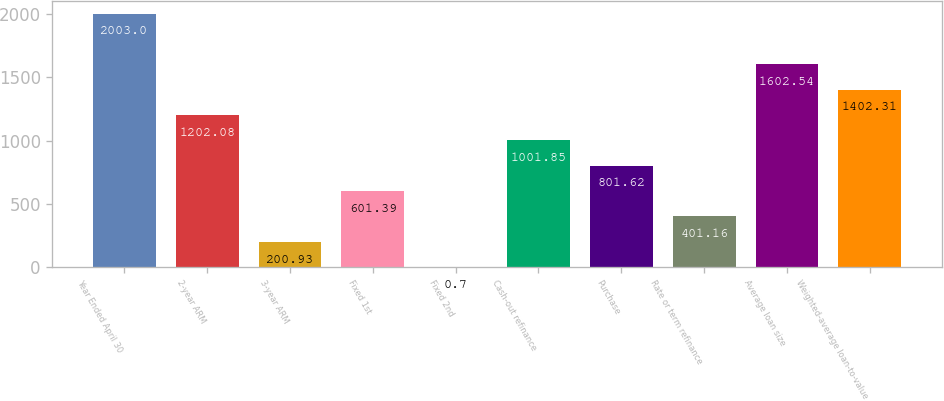Convert chart. <chart><loc_0><loc_0><loc_500><loc_500><bar_chart><fcel>Year Ended April 30<fcel>2-year ARM<fcel>3-year ARM<fcel>Fixed 1st<fcel>Fixed 2nd<fcel>Cash-out refinance<fcel>Purchase<fcel>Rate or term refinance<fcel>Average loan size<fcel>Weighted-average loan-to-value<nl><fcel>2003<fcel>1202.08<fcel>200.93<fcel>601.39<fcel>0.7<fcel>1001.85<fcel>801.62<fcel>401.16<fcel>1602.54<fcel>1402.31<nl></chart> 